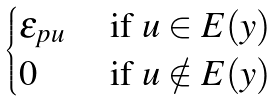Convert formula to latex. <formula><loc_0><loc_0><loc_500><loc_500>\begin{cases} \varepsilon _ { p u } & \text { if } u \in E ( y ) \\ 0 & \text { if } u \notin E ( y ) \end{cases}</formula> 